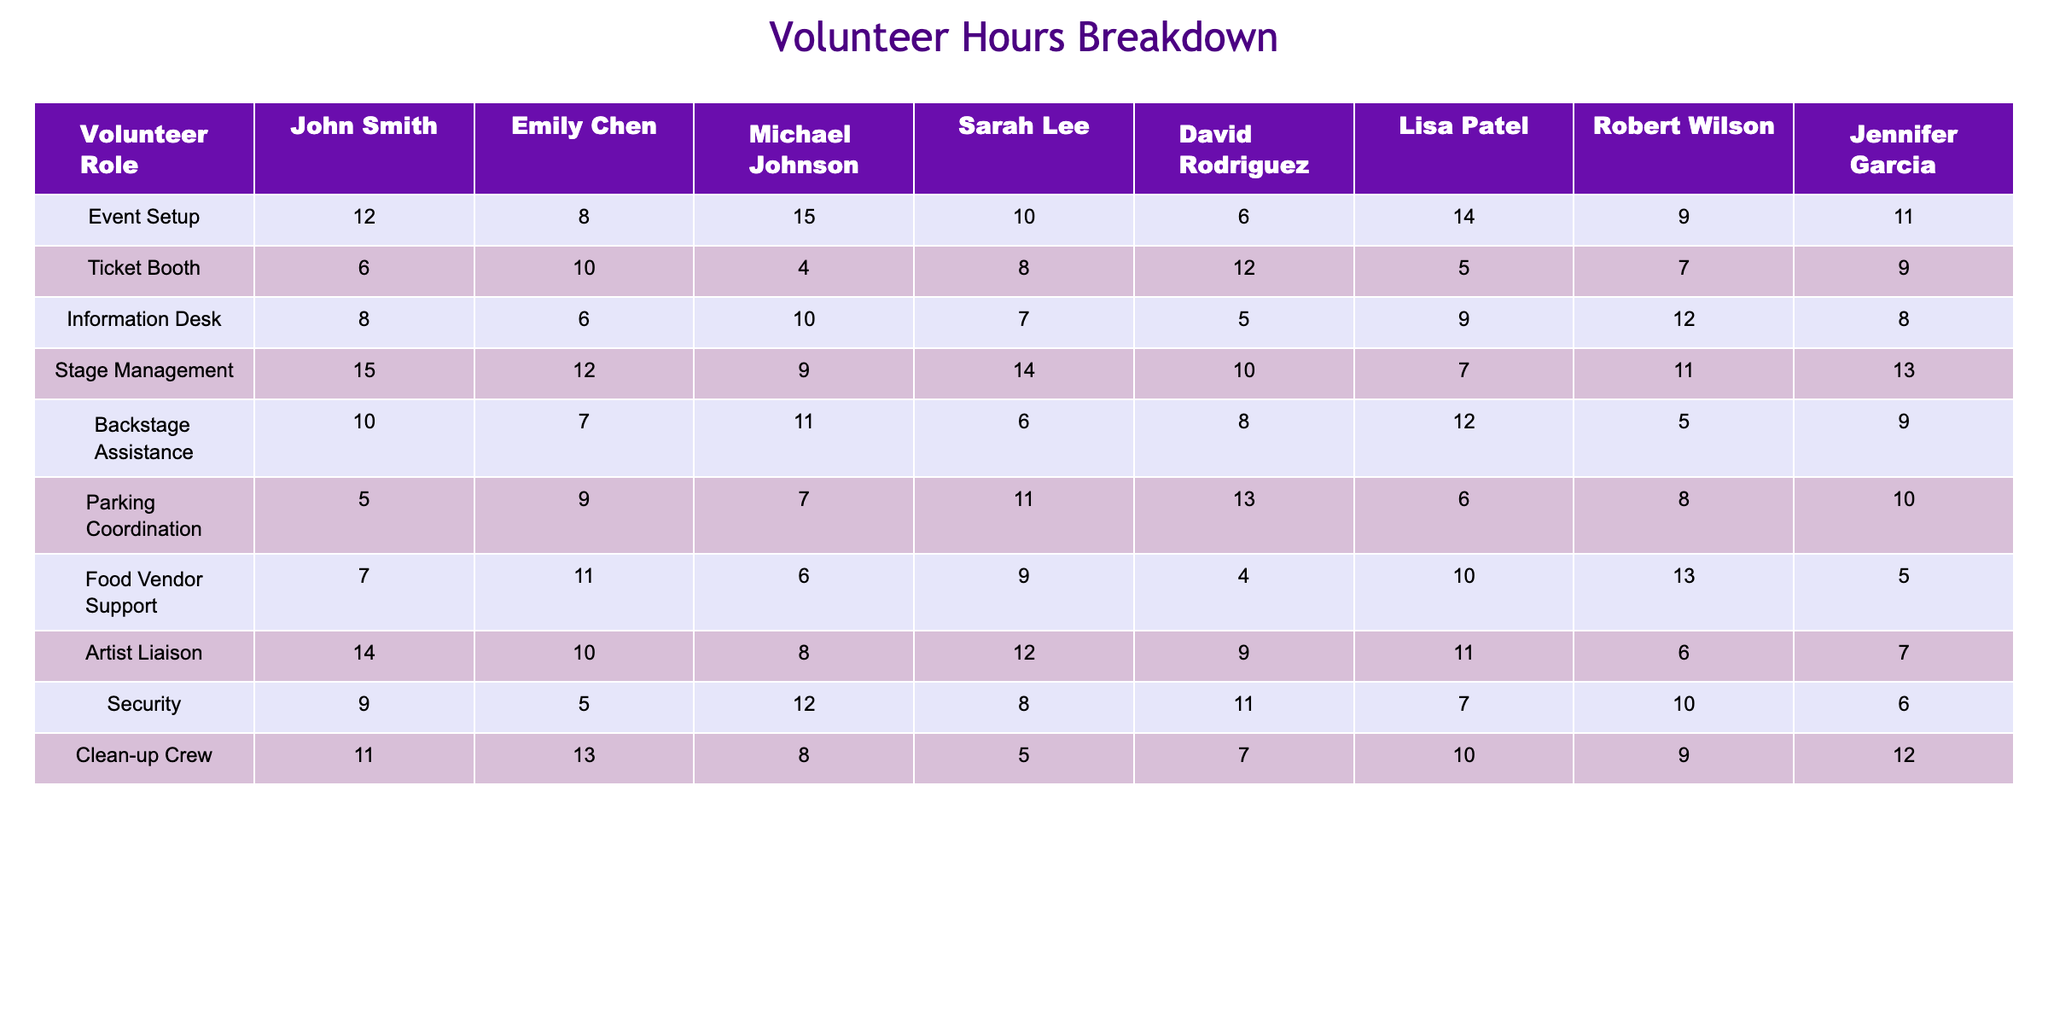What is the total number of volunteer hours contributed by Emily Chen? To find the total hours contributed by Emily Chen, I will add up the values in each role she participated in: 8 + 10 + 6 + 12 + 7 + 9 + 11 + 5 = 68.
Answer: 68 Which volunteer role did David Rodriguez contribute the least hours to? I will compare the hours contributed by David Rodriguez across all roles: Event Setup (6), Ticket Booth (12), Information Desk (5), Stage Management (10), Backstage Assistance (8), Parking Coordination (13), Food Vendor Support (4), Artist Liaison (9), Security (11), Clean-up Crew (7). The least is 4 hours in Food Vendor Support.
Answer: Food Vendor Support What is the average number of hours contributed by Robert Wilson across all roles? First, I will sum the hours contributed by Robert Wilson: 9 + 7 + 12 + 11 + 5 + 8 + 13 + 6 + 10 + 9 = 81. He participated in 10 roles, so the average is 81 / 10 = 8.1.
Answer: 8.1 Did Michael Johnson contribute more hours to Stage Management than to Event Setup? Michael Johnson contributed 9 hours to Stage Management and 15 hours to Event Setup. Since 15 is greater than 9, the answer is yes.
Answer: Yes What is the total number of volunteer hours contributed for the Information Desk? To find the total hours for the Information Desk, I will sum up the contributions from all volunteers: 8 + 6 + 10 + 7 + 5 + 9 + 12 + 8 = 65.
Answer: 65 Who contributed the highest number of hours for the Event Setup role? I will compare the hours for the Event Setup role from each volunteer: John Smith (12), Emily Chen (8), Michael Johnson (15), Sarah Lee (10), David Rodriguez (6), Lisa Patel (14), Robert Wilson (9), Jennifer Garcia (11). The highest is 15 hours by Michael Johnson.
Answer: Michael Johnson What is the difference between the total hours contributed by Sarah Lee and Lisa Patel? First, I will sum the hours for Sarah Lee: 10 + 8 + 7 + 14 + 6 + 11 + 9 + 12 = 87, and for Lisa Patel: 14 + 5 + 9 + 7 + 12 + 10 + 10 + 10 = 77. The difference is 87 - 77 = 10.
Answer: 10 Which role has the highest contribution from local residents combined? I will sum the volunteer hours for each role: Event Setup (12+8+15+10+6+14+9+11 = 85), Ticket Booth (6+10+4+8+12+5+7+9 = 61), Information Desk (65), Stage Management (96), Backstage Assistance (68), Parking Coordination (69), Food Vendor Support (66), Artist Liaison (88), Security (67), Clean-up Crew (69). The highest is 96 hours for Stage Management.
Answer: Stage Management Is the total number of hours contributed by the Clean-up Crew greater than the total number of hours for the Ticket Booth? Total for Clean-up Crew: 11 + 13 + 8 + 5 + 7 + 10 + 9 + 12 = 75. Total for Ticket Booth: 61. Since 75 is greater than 61, the answer is yes.
Answer: Yes What is the total number of hours volunteered by all participants for the Parking Coordination role? The total hours for Parking Coordination is: 5 + 9 + 7 + 11 + 13 + 6 + 8 + 10 = 69.
Answer: 69 